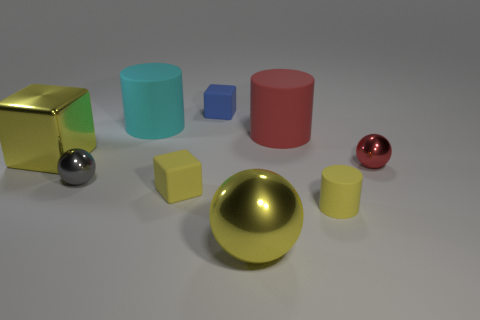There is a yellow metal block; is its size the same as the red rubber thing that is behind the red ball?
Provide a short and direct response. Yes. Is the number of matte cylinders that are to the left of the gray thing the same as the number of big yellow spheres that are to the right of the tiny matte cylinder?
Offer a terse response. Yes. The metal thing that is the same color as the large ball is what shape?
Make the answer very short. Cube. What is the material of the yellow block behind the red ball?
Offer a very short reply. Metal. Is the yellow shiny cube the same size as the cyan matte cylinder?
Your answer should be compact. Yes. Is the number of metallic spheres that are behind the red matte object greater than the number of large cyan matte cylinders?
Keep it short and to the point. No. There is a gray thing that is the same material as the big yellow cube; what size is it?
Your answer should be very brief. Small. There is a red rubber cylinder; are there any big cylinders behind it?
Provide a short and direct response. Yes. Does the small gray thing have the same shape as the tiny red object?
Keep it short and to the point. Yes. How big is the matte cylinder in front of the yellow shiny thing that is on the left side of the large shiny object that is right of the large cyan rubber cylinder?
Your answer should be compact. Small. 